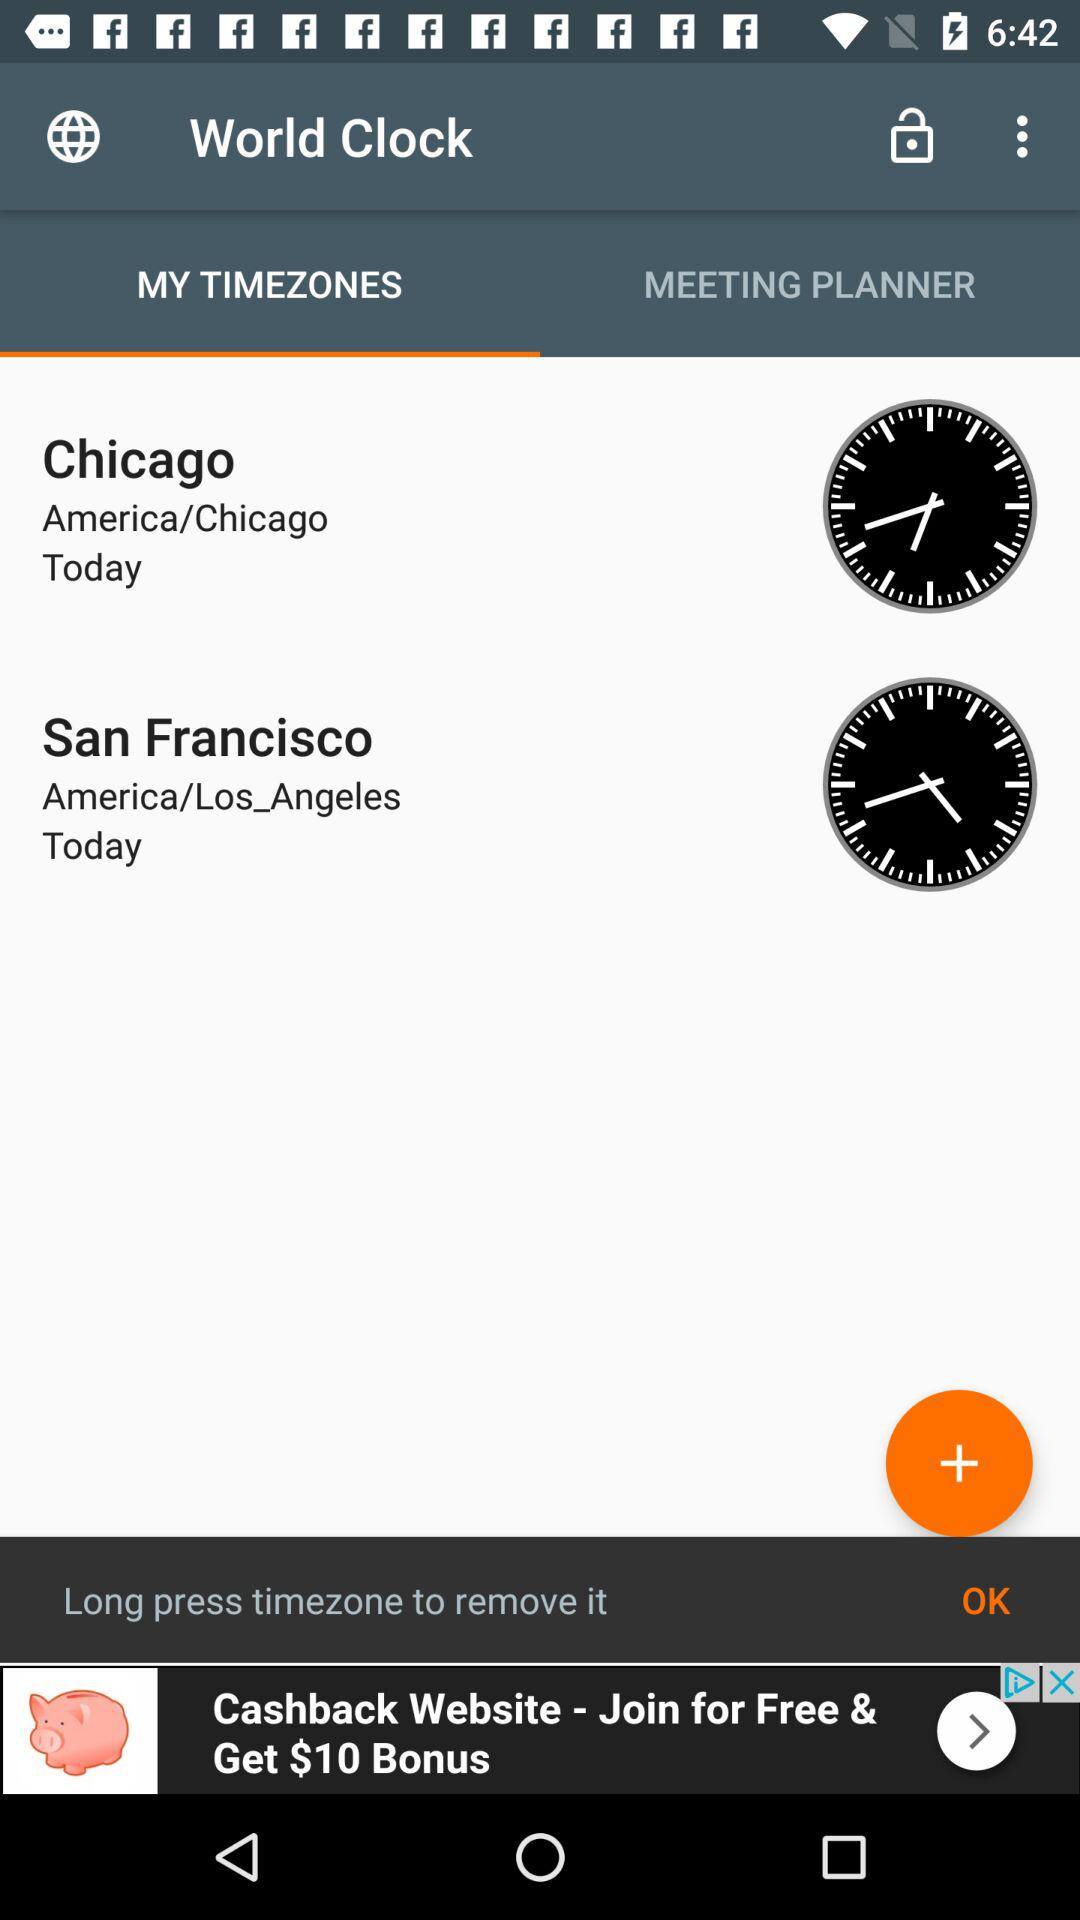What is today's time showing in San Francisco?
When the provided information is insufficient, respond with <no answer>. <no answer> 